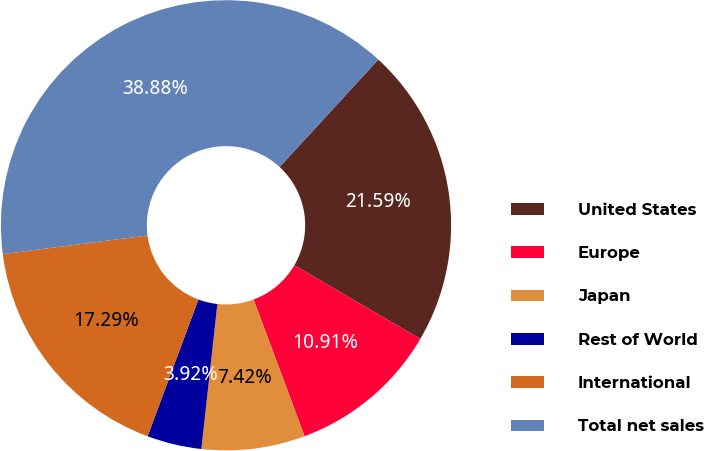<chart> <loc_0><loc_0><loc_500><loc_500><pie_chart><fcel>United States<fcel>Europe<fcel>Japan<fcel>Rest of World<fcel>International<fcel>Total net sales<nl><fcel>21.59%<fcel>10.91%<fcel>7.42%<fcel>3.92%<fcel>17.29%<fcel>38.88%<nl></chart> 